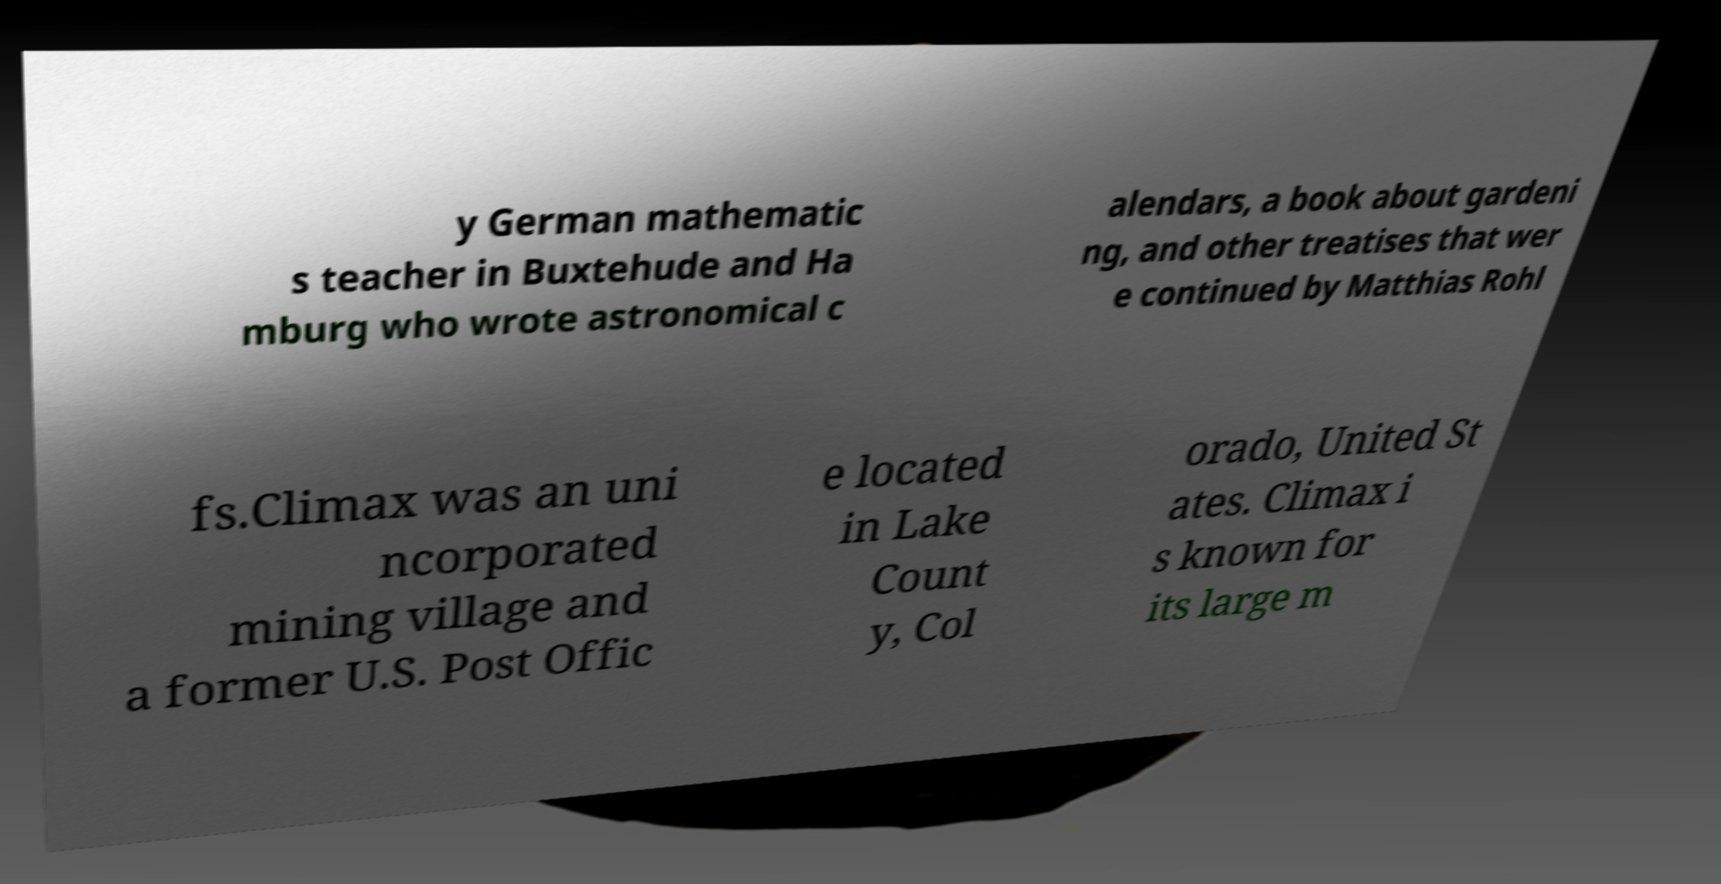What messages or text are displayed in this image? I need them in a readable, typed format. y German mathematic s teacher in Buxtehude and Ha mburg who wrote astronomical c alendars, a book about gardeni ng, and other treatises that wer e continued by Matthias Rohl fs.Climax was an uni ncorporated mining village and a former U.S. Post Offic e located in Lake Count y, Col orado, United St ates. Climax i s known for its large m 